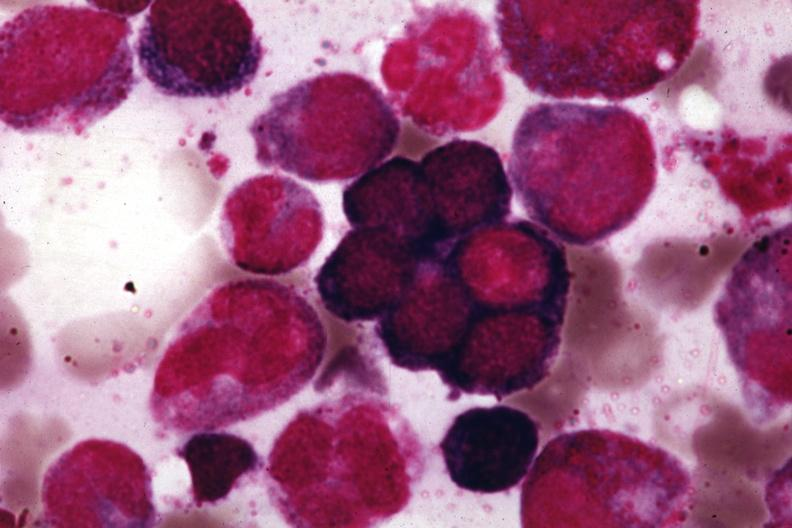s cardiovascular present?
Answer the question using a single word or phrase. No 